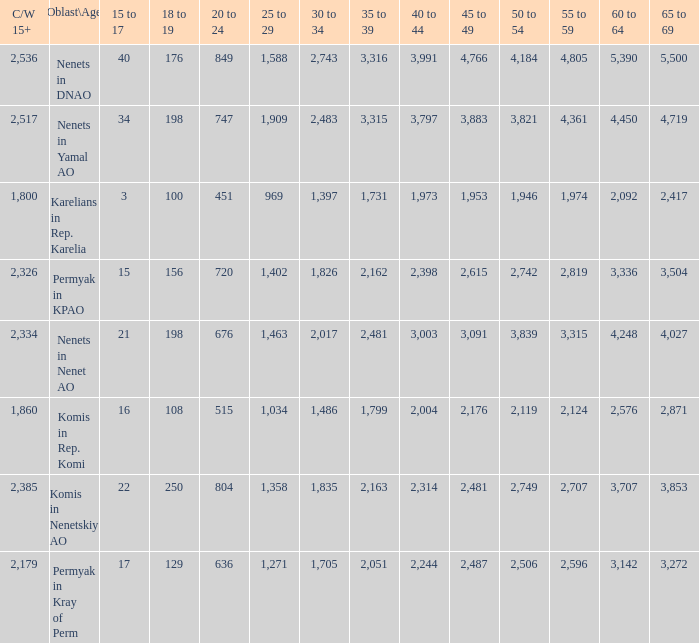What is the total 60 to 64 when the Oblast\Age is Nenets in Yamal AO, and the 45 to 49 is bigger than 3,883? None. 